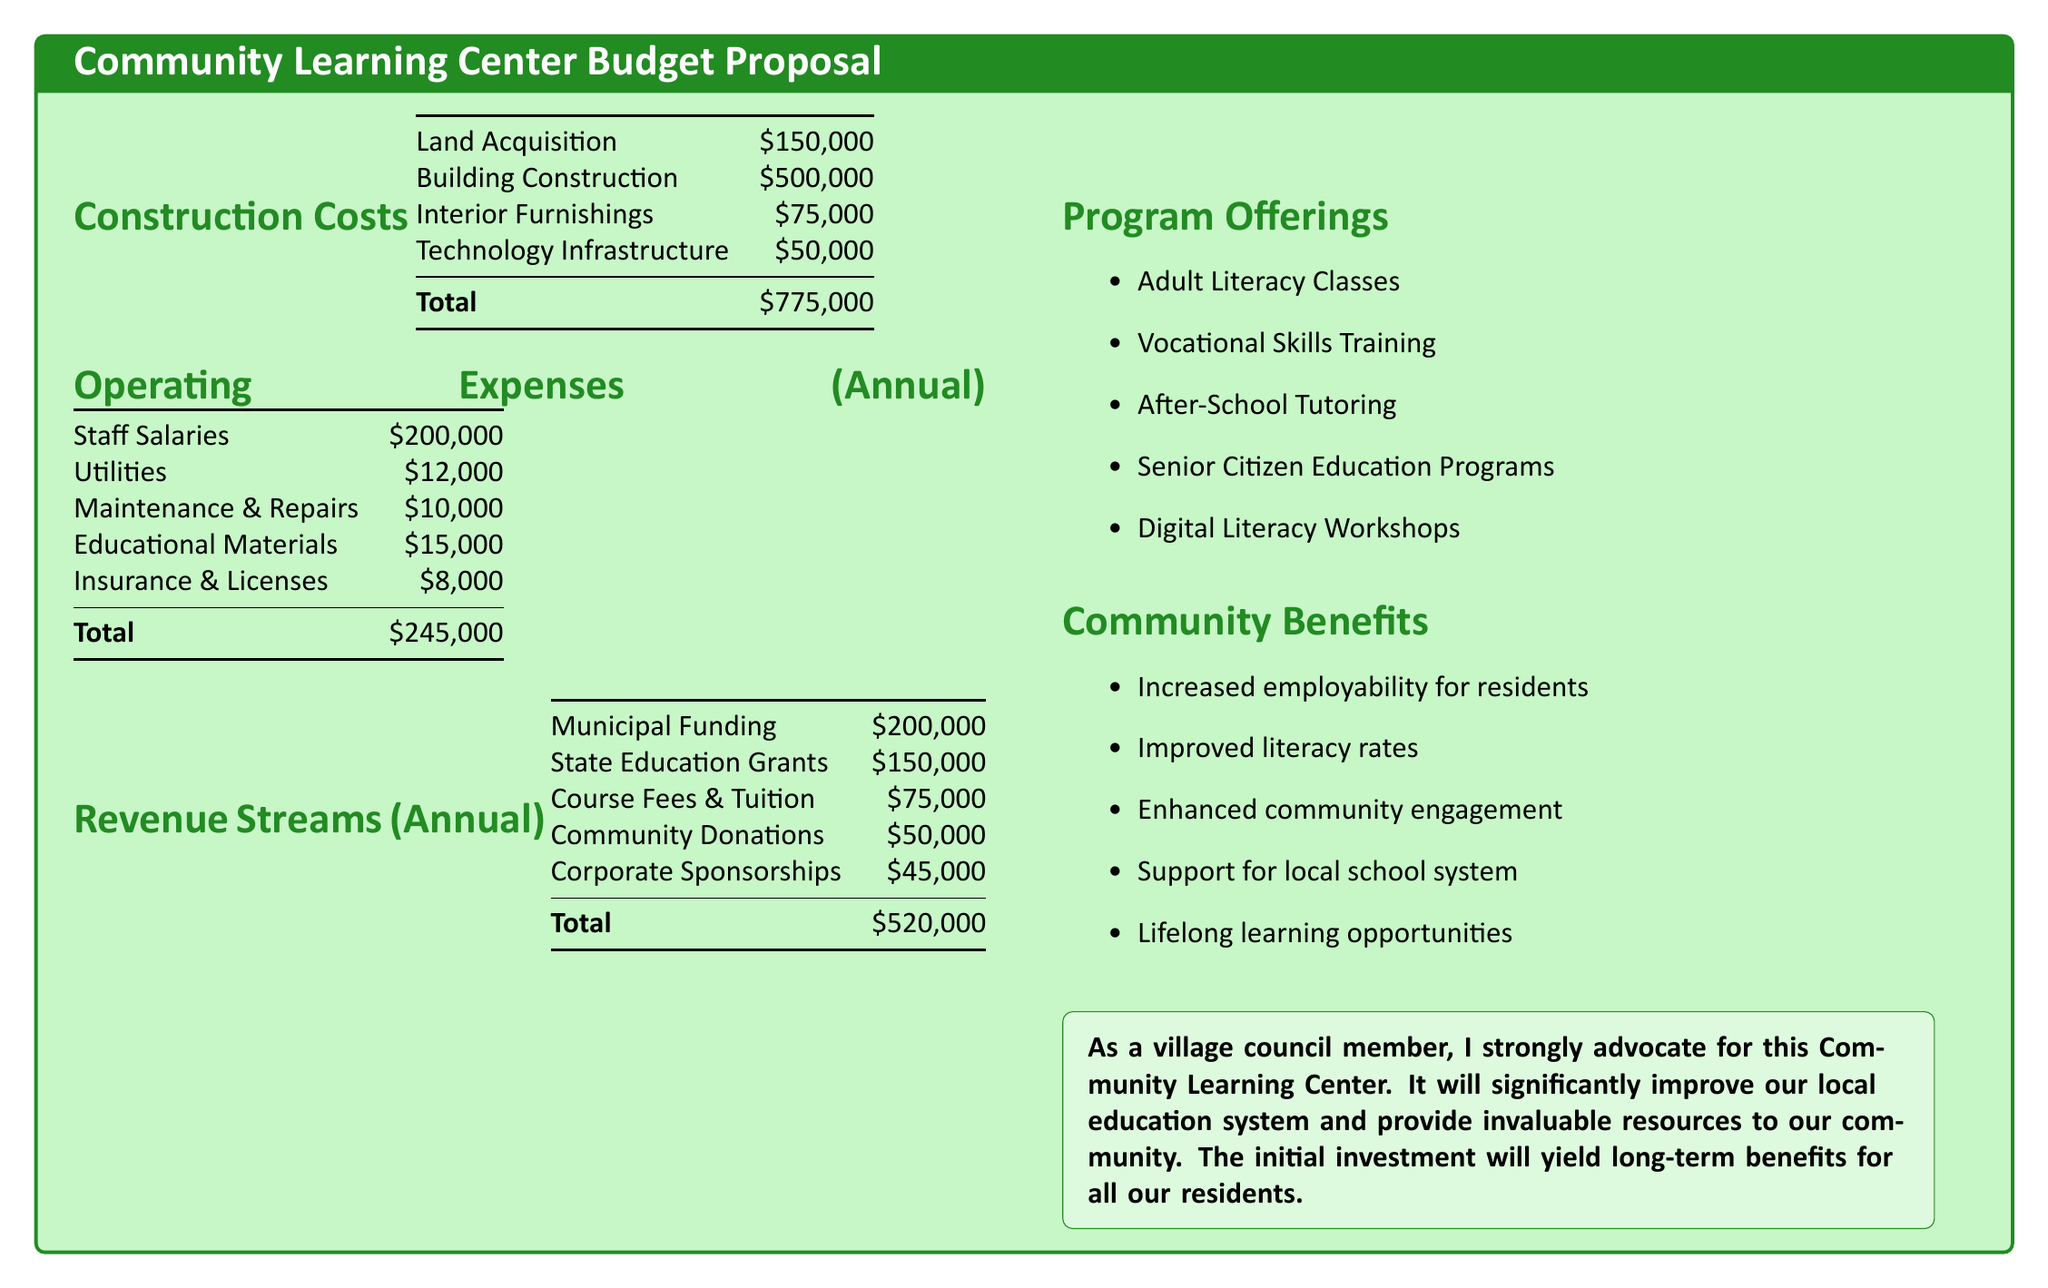What are the total construction costs? The total construction costs are detailed in the document under "Construction Costs," which sums up to $775,000.
Answer: $775,000 What is the annual budget for staff salaries? The document clearly lists the annual budget for staff salaries under "Operating Expenses," which is $200,000.
Answer: $200,000 What is the total for Community Donations? The document lists Community Donations as one of the revenue streams, which amounts to $50,000.
Answer: $50,000 How much is allocated for Educational Materials? The budget has an allocation for Educational Materials listed under "Operating Expenses," which is $15,000.
Answer: $15,000 What is the difference between total revenue and total operating expenses? The total revenue is $520,000, and total operating expenses are $245,000; the difference is calculated by subtracting operating expenses from revenue.
Answer: $275,000 How many program offerings are listed? The document includes a section titled "Program Offerings," which lists five different programs.
Answer: Five What is the main purpose of establishing the Community Learning Center? The document mentions the purpose in the advocacy statement, emphasizing the improvement of the local education system and resources for the community.
Answer: Improve local education What is the total amount allocated for Technology Infrastructure? The budget specifies that the amount allocated for Technology Infrastructure is $50,000.
Answer: $50,000 What is the highest construction cost item? The document lists Building Construction as the highest item under "Construction Costs" at $500,000.
Answer: Building Construction 